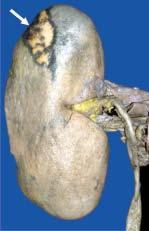s microscopy slightly depressed on the surface?
Answer the question using a single word or phrase. No 